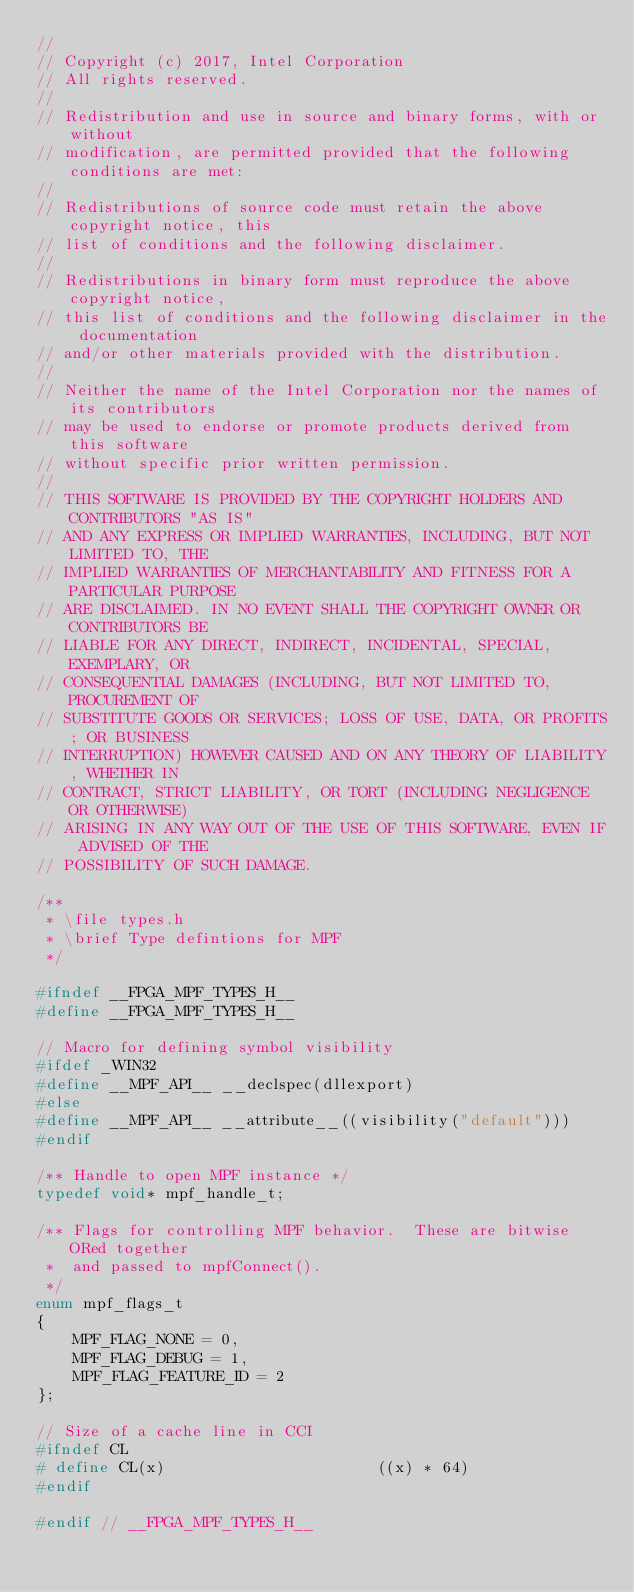Convert code to text. <code><loc_0><loc_0><loc_500><loc_500><_C_>//
// Copyright (c) 2017, Intel Corporation
// All rights reserved.
//
// Redistribution and use in source and binary forms, with or without
// modification, are permitted provided that the following conditions are met:
//
// Redistributions of source code must retain the above copyright notice, this
// list of conditions and the following disclaimer.
//
// Redistributions in binary form must reproduce the above copyright notice,
// this list of conditions and the following disclaimer in the documentation
// and/or other materials provided with the distribution.
//
// Neither the name of the Intel Corporation nor the names of its contributors
// may be used to endorse or promote products derived from this software
// without specific prior written permission.
//
// THIS SOFTWARE IS PROVIDED BY THE COPYRIGHT HOLDERS AND CONTRIBUTORS "AS IS"
// AND ANY EXPRESS OR IMPLIED WARRANTIES, INCLUDING, BUT NOT LIMITED TO, THE
// IMPLIED WARRANTIES OF MERCHANTABILITY AND FITNESS FOR A PARTICULAR PURPOSE
// ARE DISCLAIMED. IN NO EVENT SHALL THE COPYRIGHT OWNER OR CONTRIBUTORS BE
// LIABLE FOR ANY DIRECT, INDIRECT, INCIDENTAL, SPECIAL, EXEMPLARY, OR
// CONSEQUENTIAL DAMAGES (INCLUDING, BUT NOT LIMITED TO, PROCUREMENT OF
// SUBSTITUTE GOODS OR SERVICES; LOSS OF USE, DATA, OR PROFITS; OR BUSINESS
// INTERRUPTION) HOWEVER CAUSED AND ON ANY THEORY OF LIABILITY, WHETHER IN
// CONTRACT, STRICT LIABILITY, OR TORT (INCLUDING NEGLIGENCE OR OTHERWISE)
// ARISING IN ANY WAY OUT OF THE USE OF THIS SOFTWARE, EVEN IF ADVISED OF THE
// POSSIBILITY OF SUCH DAMAGE.

/**
 * \file types.h
 * \brief Type defintions for MPF
 */

#ifndef __FPGA_MPF_TYPES_H__
#define __FPGA_MPF_TYPES_H__

// Macro for defining symbol visibility
#ifdef _WIN32
#define __MPF_API__ __declspec(dllexport)
#else
#define __MPF_API__ __attribute__((visibility("default")))
#endif

/** Handle to open MPF instance */
typedef void* mpf_handle_t;

/** Flags for controlling MPF behavior.  These are bitwise ORed together
 *  and passed to mpfConnect().
 */
enum mpf_flags_t
{
    MPF_FLAG_NONE = 0,
    MPF_FLAG_DEBUG = 1,
    MPF_FLAG_FEATURE_ID = 2
};

// Size of a cache line in CCI
#ifndef CL
# define CL(x)                       ((x) * 64)
#endif

#endif // __FPGA_MPF_TYPES_H__
</code> 